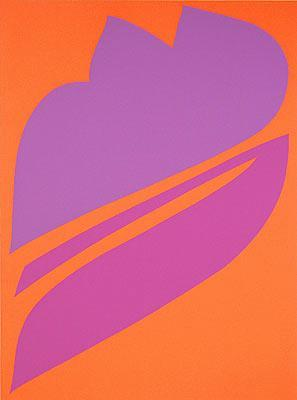Can you explore the symbolism of the shape used in this artwork? Certainly! The central purple shape in this abstract artwork, which resembles a leaf or a flame, might symbolize growth or transformation. The flowing, intertwining lines could represent the connectivity of various aspects of life or nature, suggesting a dynamic interplay between different forces or elements. The abstract form leaves much to interpretation, inviting viewers to contemplate its meaning based on their perspectives and experiences. 